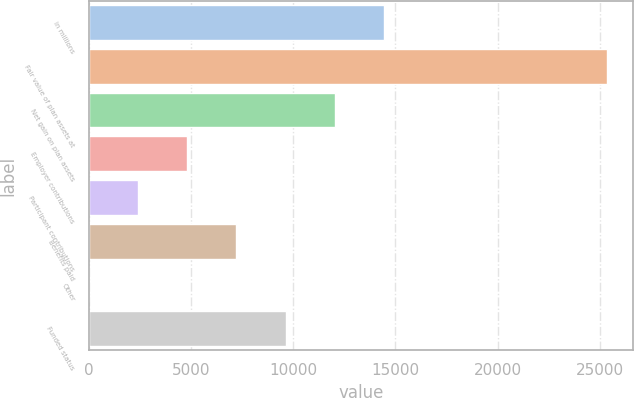<chart> <loc_0><loc_0><loc_500><loc_500><bar_chart><fcel>in millions<fcel>Fair value of plan assets at<fcel>Net gain on plan assets<fcel>Employer contributions<fcel>Participant contributions<fcel>Benefits paid<fcel>Other<fcel>Funded status<nl><fcel>14460<fcel>25371.5<fcel>12050.5<fcel>4822<fcel>2412.5<fcel>7231.5<fcel>3<fcel>9641<nl></chart> 